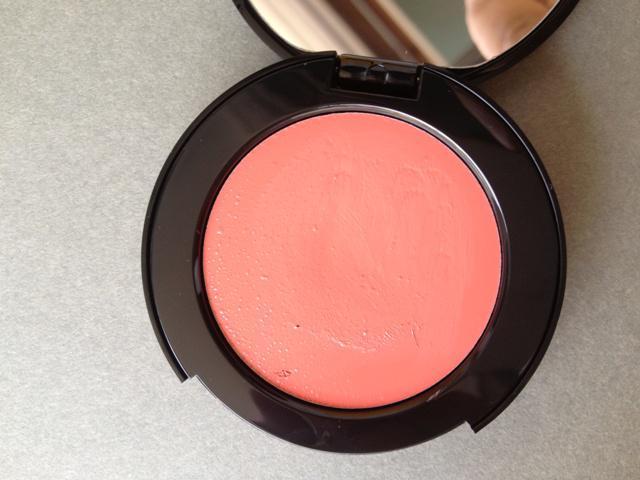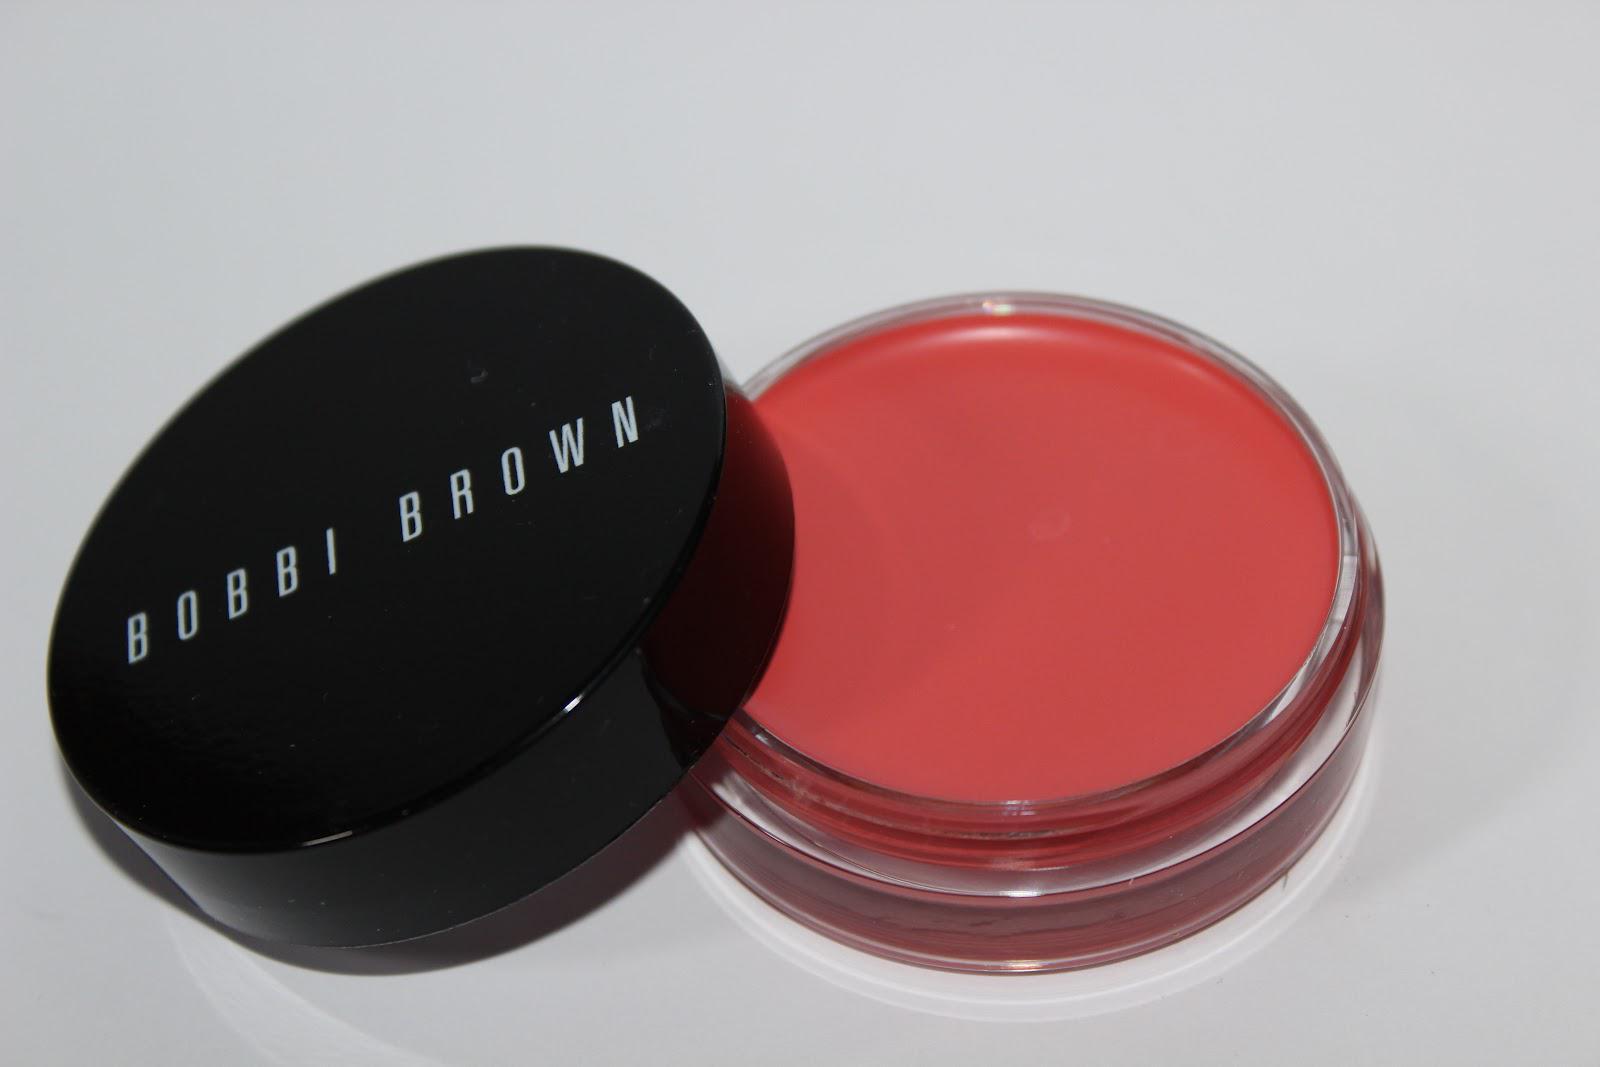The first image is the image on the left, the second image is the image on the right. For the images displayed, is the sentence "Each image contains exactly four round disc-shaped items." factually correct? Answer yes or no. No. The first image is the image on the left, the second image is the image on the right. Given the left and right images, does the statement "There are two open makeup with their lids next to them in the right image." hold true? Answer yes or no. No. 